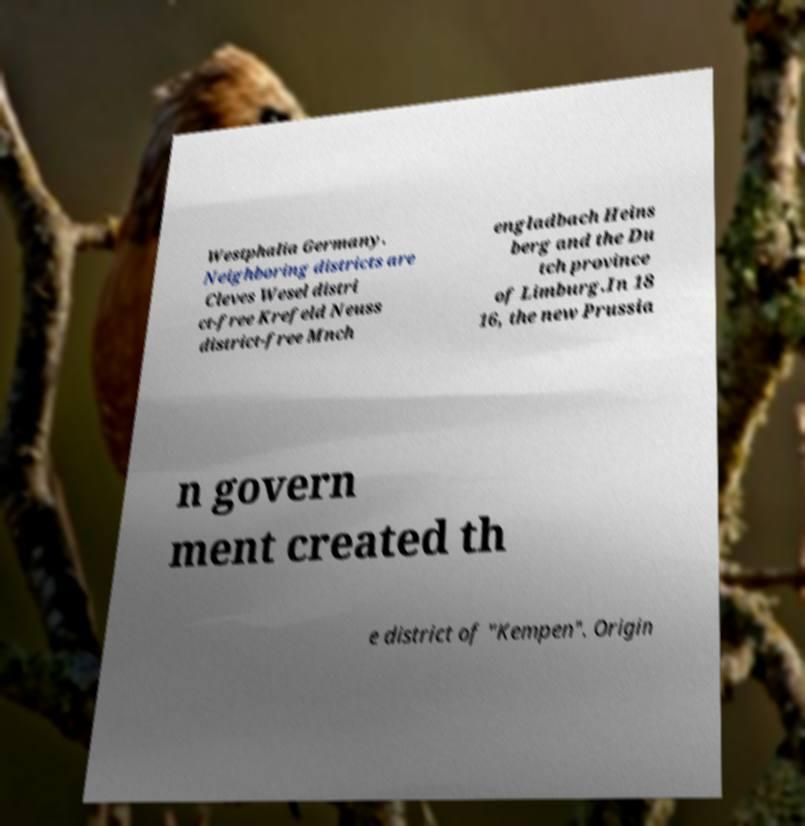Can you read and provide the text displayed in the image?This photo seems to have some interesting text. Can you extract and type it out for me? Westphalia Germany. Neighboring districts are Cleves Wesel distri ct-free Krefeld Neuss district-free Mnch engladbach Heins berg and the Du tch province of Limburg.In 18 16, the new Prussia n govern ment created th e district of "Kempen". Origin 